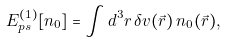<formula> <loc_0><loc_0><loc_500><loc_500>E _ { p s } ^ { ( 1 ) } [ n _ { 0 } ] = \int { d ^ { 3 } r \, { \delta } v ( \vec { r } ) \, { n _ { 0 } ( \vec { r } ) } } ,</formula> 